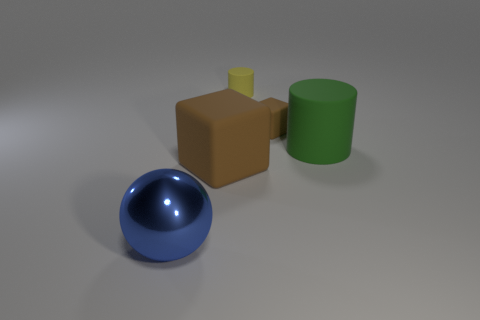Subtract all brown blocks. How many were subtracted if there are1brown blocks left? 1 Add 2 blue shiny balls. How many objects exist? 7 Subtract all cylinders. How many objects are left? 3 Subtract 0 gray balls. How many objects are left? 5 Subtract all large cyan matte cylinders. Subtract all brown things. How many objects are left? 3 Add 4 blue metal things. How many blue metal things are left? 5 Add 3 big brown rubber things. How many big brown rubber things exist? 4 